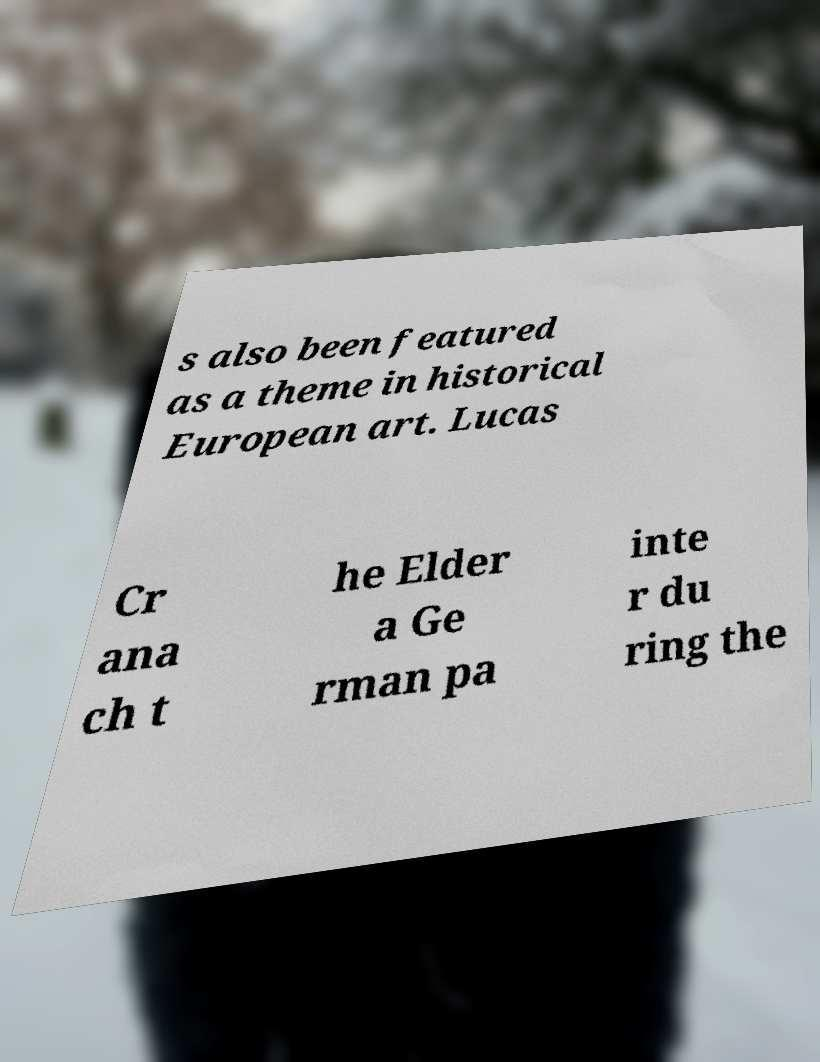I need the written content from this picture converted into text. Can you do that? s also been featured as a theme in historical European art. Lucas Cr ana ch t he Elder a Ge rman pa inte r du ring the 